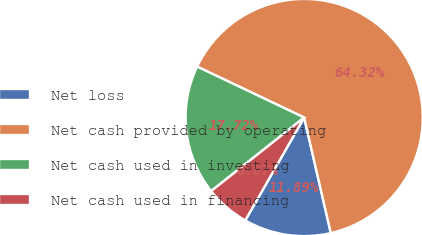Convert chart. <chart><loc_0><loc_0><loc_500><loc_500><pie_chart><fcel>Net loss<fcel>Net cash provided by operating<fcel>Net cash used in investing<fcel>Net cash used in financing<nl><fcel>11.89%<fcel>64.33%<fcel>17.72%<fcel>6.07%<nl></chart> 